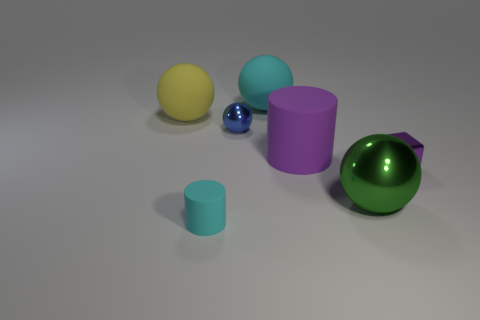How many other objects are the same material as the cyan sphere?
Offer a very short reply. 3. Do the block and the metallic ball that is in front of the small purple thing have the same size?
Offer a terse response. No. Are there more tiny purple metallic cubes right of the shiny block than red shiny blocks?
Your answer should be very brief. No. There is a yellow thing that is the same material as the small cyan cylinder; what is its size?
Ensure brevity in your answer.  Large. Are there any tiny metallic cubes of the same color as the large rubber cylinder?
Your response must be concise. Yes. How many things are either large green balls or objects that are to the right of the big yellow thing?
Ensure brevity in your answer.  6. Is the number of big brown cylinders greater than the number of tiny blue spheres?
Your answer should be compact. No. The matte cylinder that is the same color as the small metallic cube is what size?
Your response must be concise. Large. Are there any tiny purple blocks that have the same material as the large cyan ball?
Give a very brief answer. No. What shape is the object that is both in front of the small shiny block and right of the blue sphere?
Your response must be concise. Sphere. 